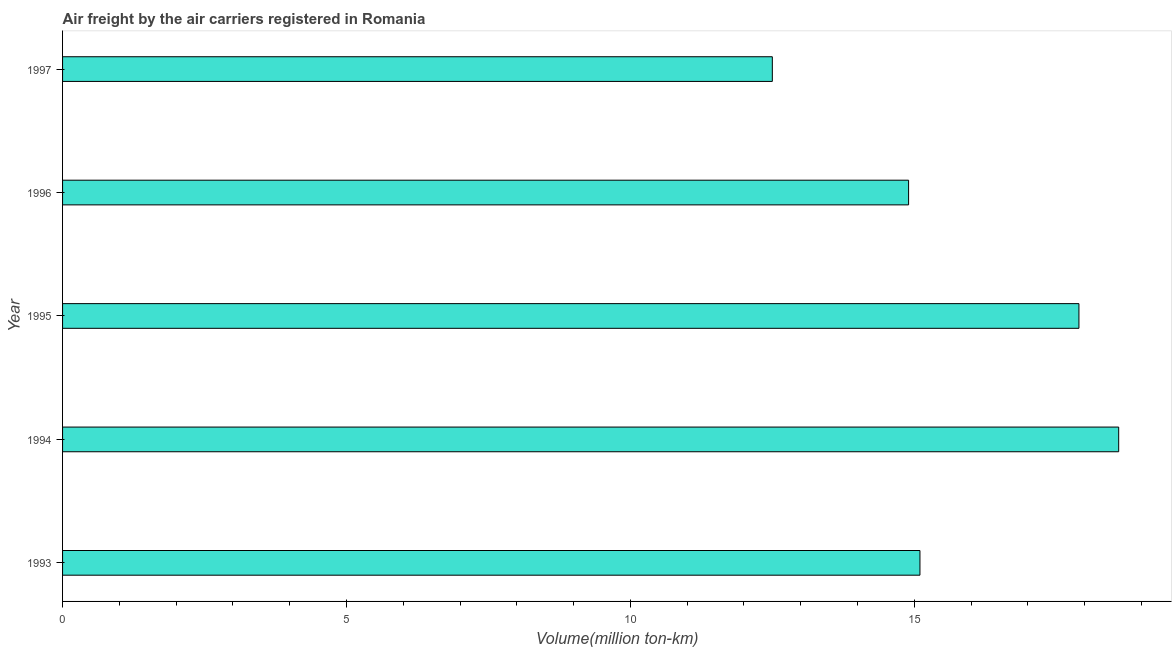Does the graph contain any zero values?
Your answer should be very brief. No. Does the graph contain grids?
Provide a short and direct response. No. What is the title of the graph?
Your answer should be very brief. Air freight by the air carriers registered in Romania. What is the label or title of the X-axis?
Your answer should be very brief. Volume(million ton-km). What is the air freight in 1996?
Offer a very short reply. 14.9. Across all years, what is the maximum air freight?
Ensure brevity in your answer.  18.6. Across all years, what is the minimum air freight?
Your answer should be very brief. 12.5. In which year was the air freight maximum?
Give a very brief answer. 1994. What is the sum of the air freight?
Give a very brief answer. 79. What is the difference between the air freight in 1993 and 1994?
Your response must be concise. -3.5. What is the median air freight?
Your answer should be very brief. 15.1. In how many years, is the air freight greater than 8 million ton-km?
Give a very brief answer. 5. What is the ratio of the air freight in 1994 to that in 1997?
Give a very brief answer. 1.49. Is the difference between the air freight in 1994 and 1997 greater than the difference between any two years?
Make the answer very short. Yes. What is the difference between the highest and the second highest air freight?
Provide a short and direct response. 0.7. Is the sum of the air freight in 1993 and 1994 greater than the maximum air freight across all years?
Offer a very short reply. Yes. What is the difference between the highest and the lowest air freight?
Give a very brief answer. 6.1. In how many years, is the air freight greater than the average air freight taken over all years?
Give a very brief answer. 2. How many bars are there?
Your answer should be very brief. 5. How many years are there in the graph?
Ensure brevity in your answer.  5. What is the difference between two consecutive major ticks on the X-axis?
Offer a terse response. 5. Are the values on the major ticks of X-axis written in scientific E-notation?
Your response must be concise. No. What is the Volume(million ton-km) of 1993?
Make the answer very short. 15.1. What is the Volume(million ton-km) of 1994?
Provide a succinct answer. 18.6. What is the Volume(million ton-km) of 1995?
Give a very brief answer. 17.9. What is the Volume(million ton-km) in 1996?
Make the answer very short. 14.9. What is the difference between the Volume(million ton-km) in 1993 and 1994?
Offer a terse response. -3.5. What is the difference between the Volume(million ton-km) in 1993 and 1995?
Make the answer very short. -2.8. What is the difference between the Volume(million ton-km) in 1993 and 1997?
Your response must be concise. 2.6. What is the difference between the Volume(million ton-km) in 1994 and 1996?
Ensure brevity in your answer.  3.7. What is the difference between the Volume(million ton-km) in 1994 and 1997?
Offer a terse response. 6.1. What is the difference between the Volume(million ton-km) in 1995 and 1996?
Offer a very short reply. 3. What is the difference between the Volume(million ton-km) in 1995 and 1997?
Make the answer very short. 5.4. What is the difference between the Volume(million ton-km) in 1996 and 1997?
Provide a short and direct response. 2.4. What is the ratio of the Volume(million ton-km) in 1993 to that in 1994?
Give a very brief answer. 0.81. What is the ratio of the Volume(million ton-km) in 1993 to that in 1995?
Your response must be concise. 0.84. What is the ratio of the Volume(million ton-km) in 1993 to that in 1996?
Ensure brevity in your answer.  1.01. What is the ratio of the Volume(million ton-km) in 1993 to that in 1997?
Provide a succinct answer. 1.21. What is the ratio of the Volume(million ton-km) in 1994 to that in 1995?
Offer a very short reply. 1.04. What is the ratio of the Volume(million ton-km) in 1994 to that in 1996?
Give a very brief answer. 1.25. What is the ratio of the Volume(million ton-km) in 1994 to that in 1997?
Provide a short and direct response. 1.49. What is the ratio of the Volume(million ton-km) in 1995 to that in 1996?
Keep it short and to the point. 1.2. What is the ratio of the Volume(million ton-km) in 1995 to that in 1997?
Offer a very short reply. 1.43. What is the ratio of the Volume(million ton-km) in 1996 to that in 1997?
Provide a short and direct response. 1.19. 